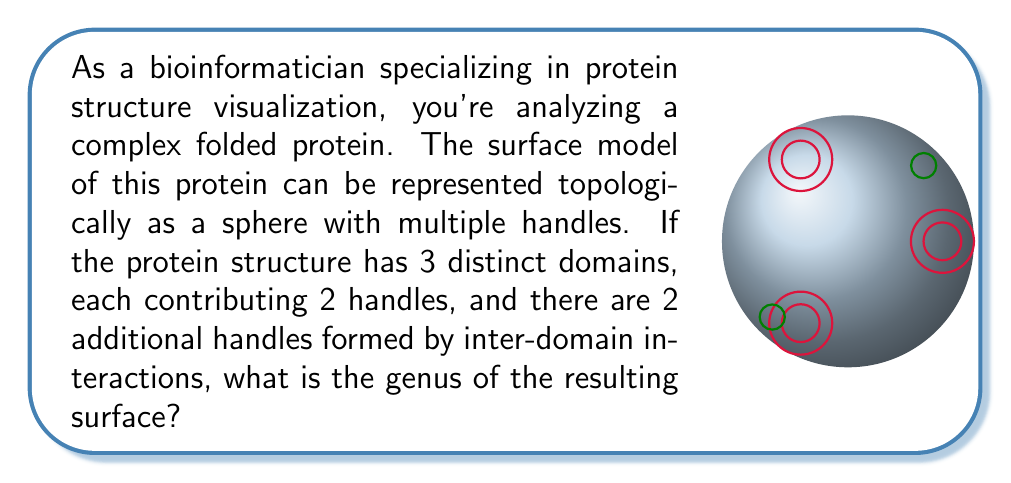Provide a solution to this math problem. To determine the genus of the surface model, we need to follow these steps:

1) Recall that the genus of a surface is the number of handles or "holes" in the surface.

2) In this problem, we have:
   - 3 distinct protein domains
   - Each domain contributes 2 handles
   - 2 additional handles from inter-domain interactions

3) Calculate the total number of handles:
   - Handles from domains: $3 \times 2 = 6$
   - Handles from inter-domain interactions: 2
   - Total handles: $6 + 2 = 8$

4) In topology, the genus of a surface is equal to the number of handles.

5) Therefore, the genus of this protein surface model is 8.

It's worth noting that this topological representation simplifies the complex 3D structure of the protein into a more manageable form, allowing for analysis of its overall shape and connectivity. This approach aligns with innovative visualization methods in bioinformatics, providing insights into protein structure that might not be immediately apparent from traditional representations.
Answer: 8 